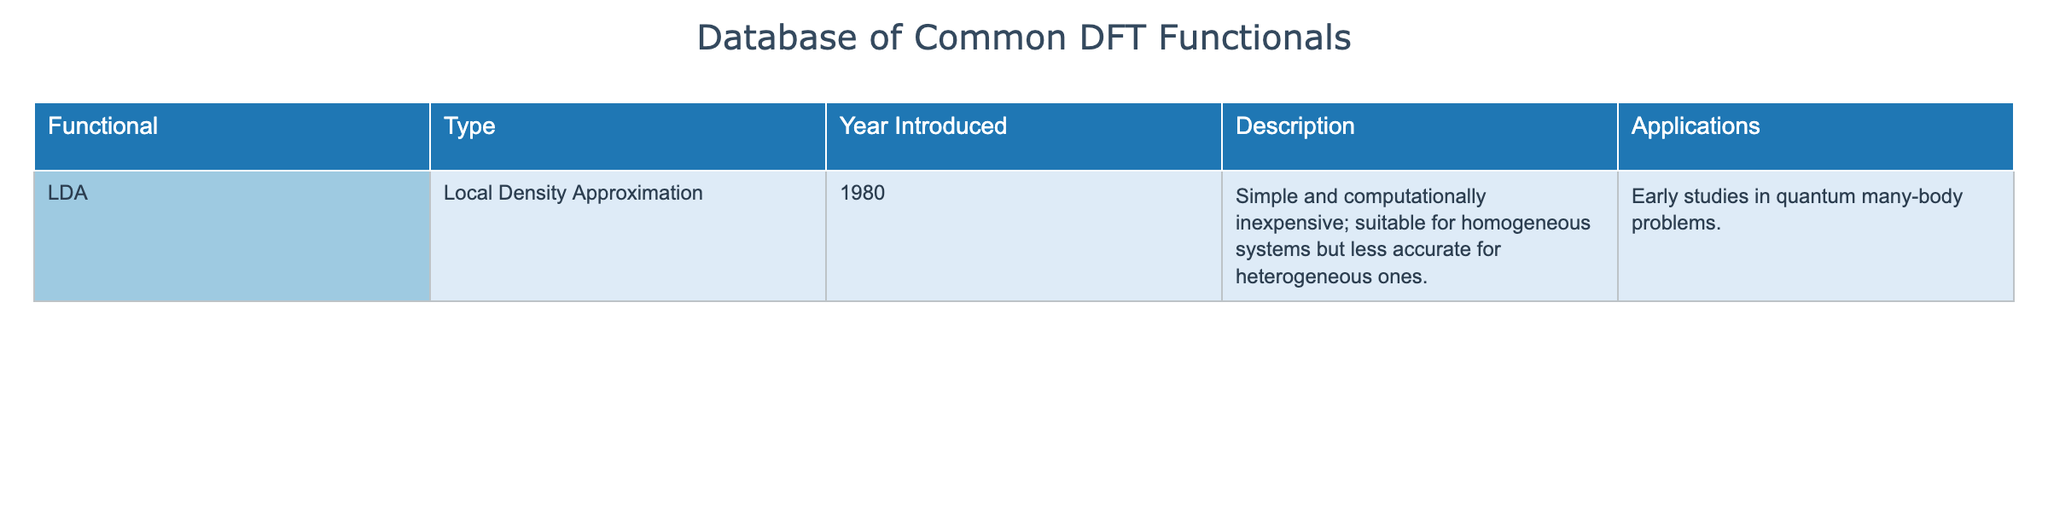What year was the LDA functional introduced? The table states that the LDA functional was introduced in the year 1980. As this is directly mentioned in the "Year Introduced" column, the answer is straightforward.
Answer: 1980 What is the type of the LDA functional? The "Type" column specifies that the LDA functional corresponds to the Local Density Approximation. This information is explicitly found in the table.
Answer: Local Density Approximation Can you name one application of the LDA functional? According to the table, one application of the LDA functional is in "Early studies in quantum many-body problems." This is taken directly from the "Applications" column of the table.
Answer: Early studies in quantum many-body problems What is the difference between the suitability of the LDA functional for homogeneous and heterogeneous systems? The table describes that the LDA functional is suitable for homogeneous systems but less accurate for heterogeneous ones. This indicates that its performance varies based on the type of system it is applied to.
Answer: Suitable for homogeneous, less accurate for heterogeneous Is the LDA functional considered computationally expensive? The table states that the LDA functional is "simple and computationally inexpensive." Therefore, the assertion that it is computationally expensive is false.
Answer: No What type of systems would the LDA functional be more applicable to based on its description? The description indicates that the LDA functional is particularly suitable for homogeneous systems. Hence, it would be more applicable to such systems as opposed to heterogeneous ones.
Answer: Homogeneous systems If another functional were to be introduced in 1990, how old would it be compared to the LDA functional based on their introduction years? Since the LDA functional was introduced in 1980, if another functional were introduced in 1990, it would be 10 years younger than the LDA functional (1990 - 1980 = 10). Thus, the age difference is 10 years.
Answer: 10 years Can you conclude whether the LDA functional is well-suited for a wide range of applications given its limitations? Given that the LDA functional is noted to be less accurate for heterogeneous systems, it suggests that despite its computational efficiency, it is less versatile for diverse applications. Thus, one could conclude it is not well-suited for a wide range of applications due to these limitations.
Answer: No 